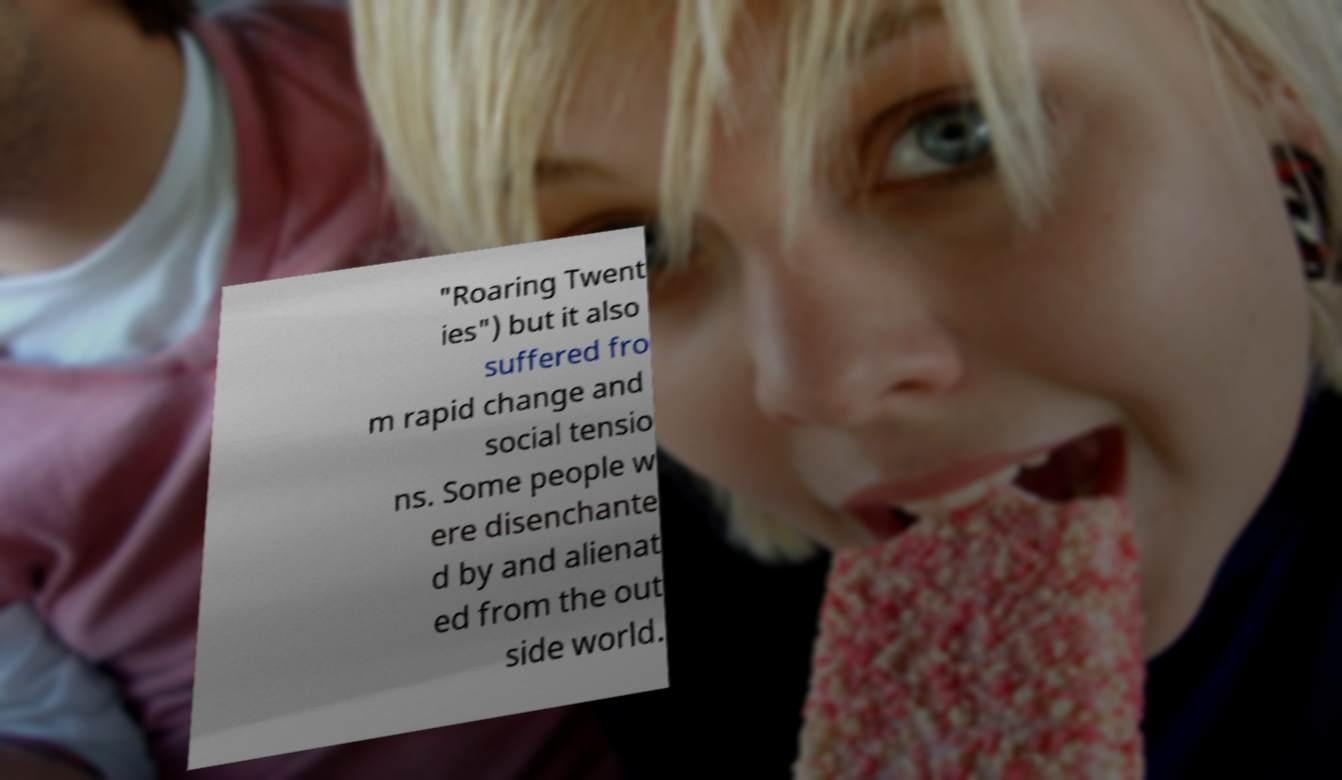Can you accurately transcribe the text from the provided image for me? "Roaring Twent ies") but it also suffered fro m rapid change and social tensio ns. Some people w ere disenchante d by and alienat ed from the out side world. 